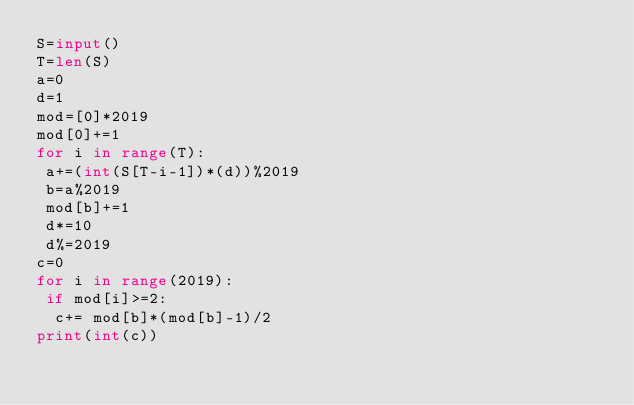<code> <loc_0><loc_0><loc_500><loc_500><_Python_>S=input()
T=len(S)
a=0
d=1
mod=[0]*2019
mod[0]+=1
for i in range(T):
 a+=(int(S[T-i-1])*(d))%2019
 b=a%2019
 mod[b]+=1
 d*=10
 d%=2019
c=0
for i in range(2019):
 if mod[i]>=2:
  c+= mod[b]*(mod[b]-1)/2
print(int(c))
</code> 